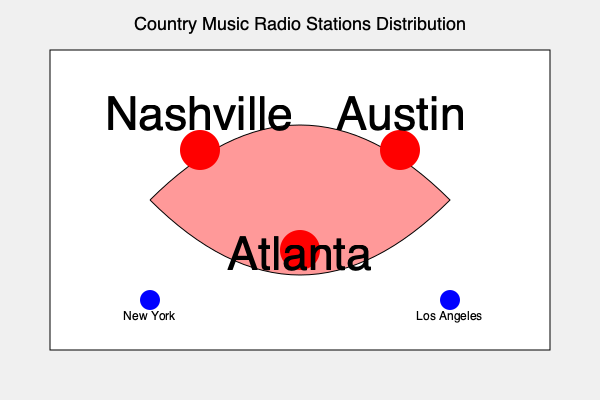Based on the map of country music radio station distribution across the United States, which region appears to have the highest concentration of stations, and how does this align with the historical development of the genre? To answer this question, we need to analyze the map and consider the historical context of country music:

1. The map shows a higher concentration of large red circles in the southeastern and south-central United States, forming a rough triangle.

2. This triangle encompasses Nashville (TN), Austin (TX), and Atlanta (GA), which are represented by larger red circles.

3. Nashville, often called the "Music City," has been the epicenter of country music since the early 20th century, home to the Grand Ole Opry and numerous record labels.

4. Austin, known as the "Live Music Capital of the World," has a rich country music scene and has produced many influential artists.

5. Atlanta, while not as prominently associated with country music, has been an important market and has contributed to the genre's evolution, particularly in terms of blending with other styles like Southern rock.

6. The southeastern region, often referred to as the "Bible Belt," has historically been a stronghold for country music due to its rural roots, traditional values, and cultural alignment with the genre's themes.

7. In contrast, major coastal cities like New York and Los Angeles (represented by smaller blue circles) have fewer country music stations, reflecting the genre's traditionally lower popularity in urban areas.

8. This distribution aligns with the historical development of country music, which originated in the rural South and Appalachia in the early 20th century before spreading to other regions.

9. The concentration of stations in the Southeast and South-central regions reflects the genre's continued strong presence in its historical heartland, despite its national and international growth.
Answer: The southeastern United States, aligning with country music's historical roots and development in the region. 